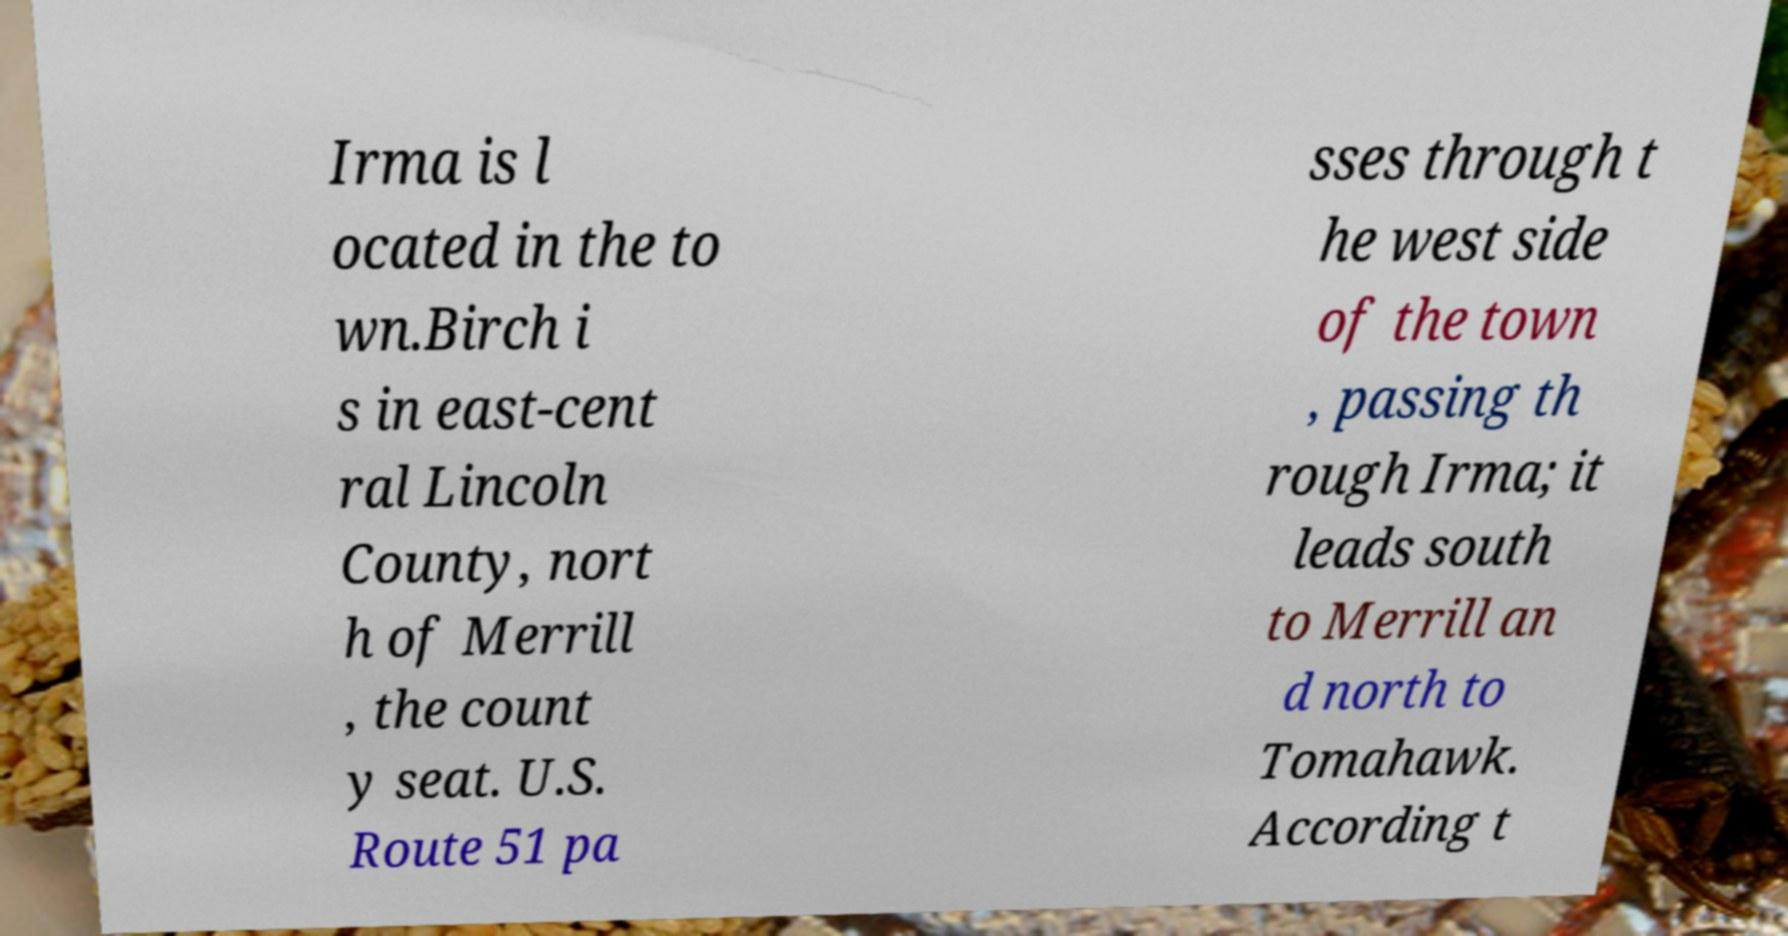Could you assist in decoding the text presented in this image and type it out clearly? Irma is l ocated in the to wn.Birch i s in east-cent ral Lincoln County, nort h of Merrill , the count y seat. U.S. Route 51 pa sses through t he west side of the town , passing th rough Irma; it leads south to Merrill an d north to Tomahawk. According t 